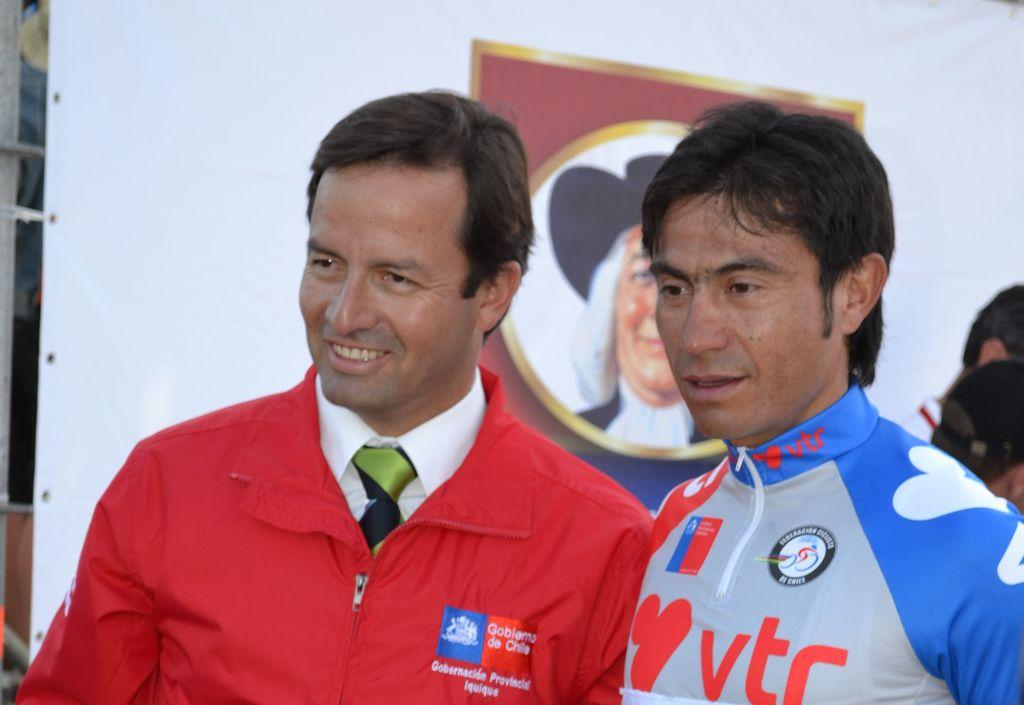<image>
Give a short and clear explanation of the subsequent image. A man in a blue and gray jacket has a vtr logo on the collar. 